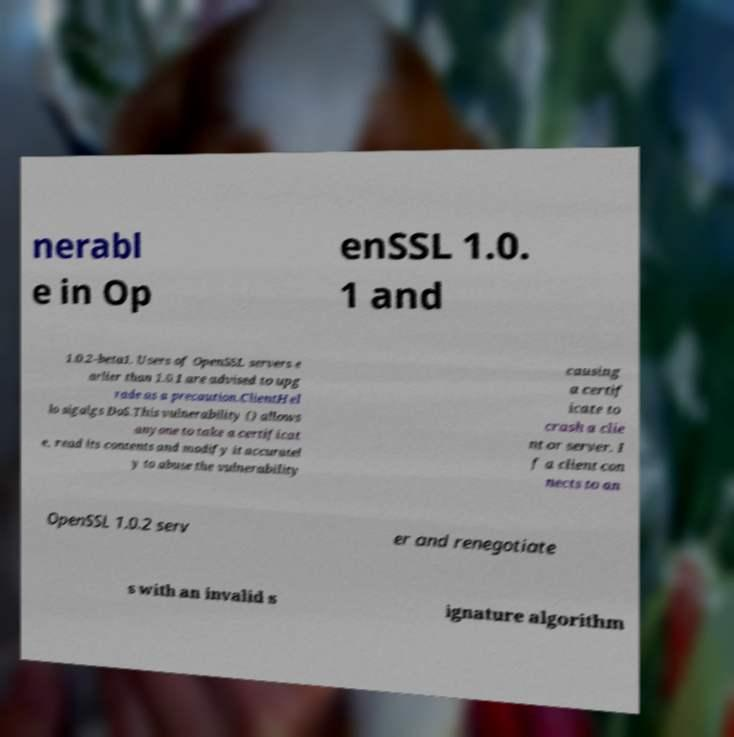Can you read and provide the text displayed in the image?This photo seems to have some interesting text. Can you extract and type it out for me? nerabl e in Op enSSL 1.0. 1 and 1.0.2-beta1. Users of OpenSSL servers e arlier than 1.0.1 are advised to upg rade as a precaution.ClientHel lo sigalgs DoS.This vulnerability () allows anyone to take a certificat e, read its contents and modify it accuratel y to abuse the vulnerability causing a certif icate to crash a clie nt or server. I f a client con nects to an OpenSSL 1.0.2 serv er and renegotiate s with an invalid s ignature algorithm 